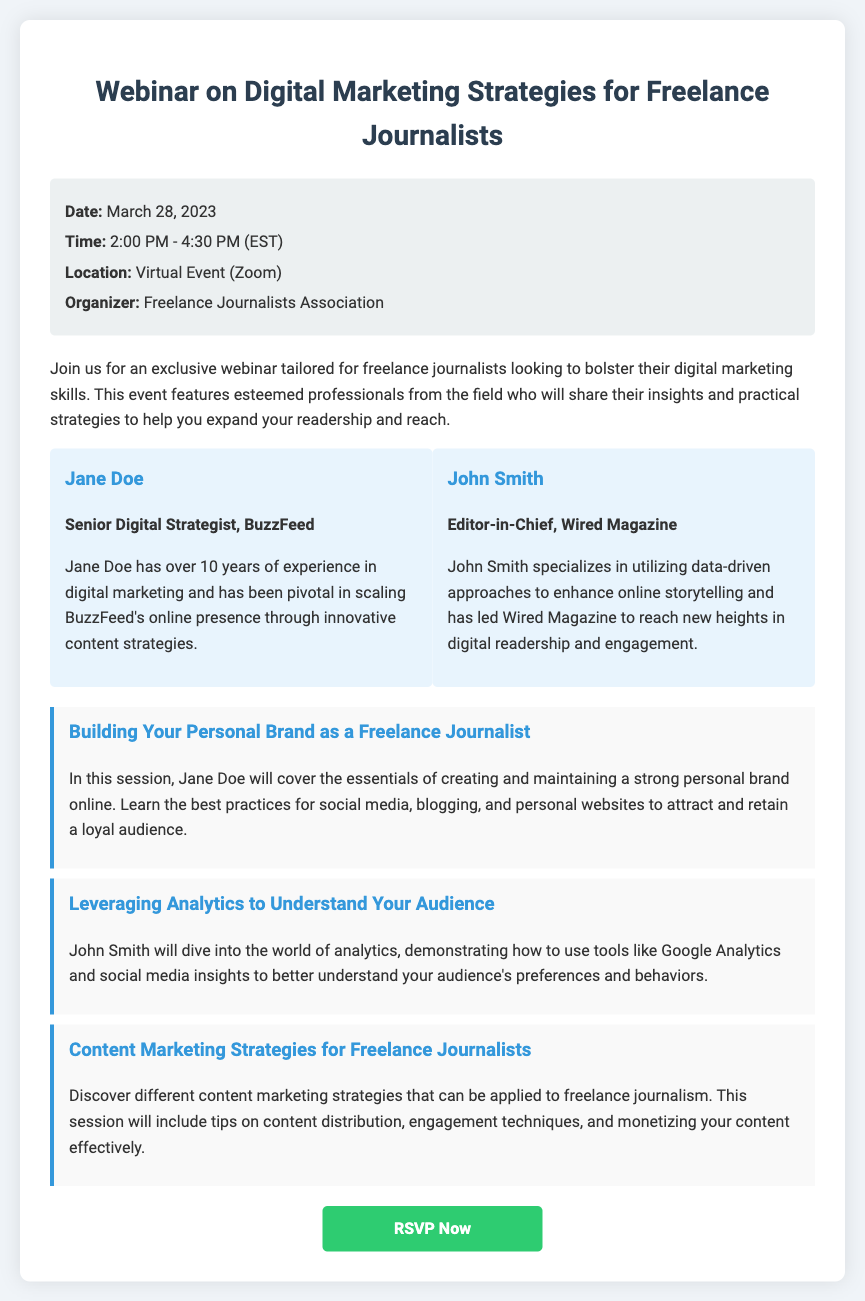What is the date of the webinar? The date of the webinar is specified in the event details section of the document, which is March 28, 2023.
Answer: March 28, 2023 What time does the webinar start? The time is provided in the event details section, which indicates the webinar starts at 2:00 PM (EST).
Answer: 2:00 PM Who is one of the keynote speakers? Keynote speakers are mentioned in the speakers section; one of them is Jane Doe.
Answer: Jane Doe What is the main topic of the first session? The session titles are listed in the sessions section; the first session is about building a personal brand.
Answer: Building Your Personal Brand as a Freelance Journalist How long is the webinar scheduled to last? The duration can be calculated from the start and end times provided (from 2:00 PM to 4:30 PM), which is 2 hours and 30 minutes.
Answer: 2 hours and 30 minutes Who is organizing the event? The organizer's information is found in the event details section, which states that it is the Freelance Journalists Association.
Answer: Freelance Journalists Association What is the primary focus of the webinar? The document describes that the webinar is tailored for freelance journalists to bolster their digital marketing skills.
Answer: Digital marketing skills How can participants RSVP for the webinar? The RSVP method is indicated at the bottom of the document with a button link that directs to an RSVP page.
Answer: RSVPing through the provided link What platform will the webinar be hosted on? The location of the webinar is mentioned in the event details, which states it will be a virtual event on Zoom.
Answer: Zoom 